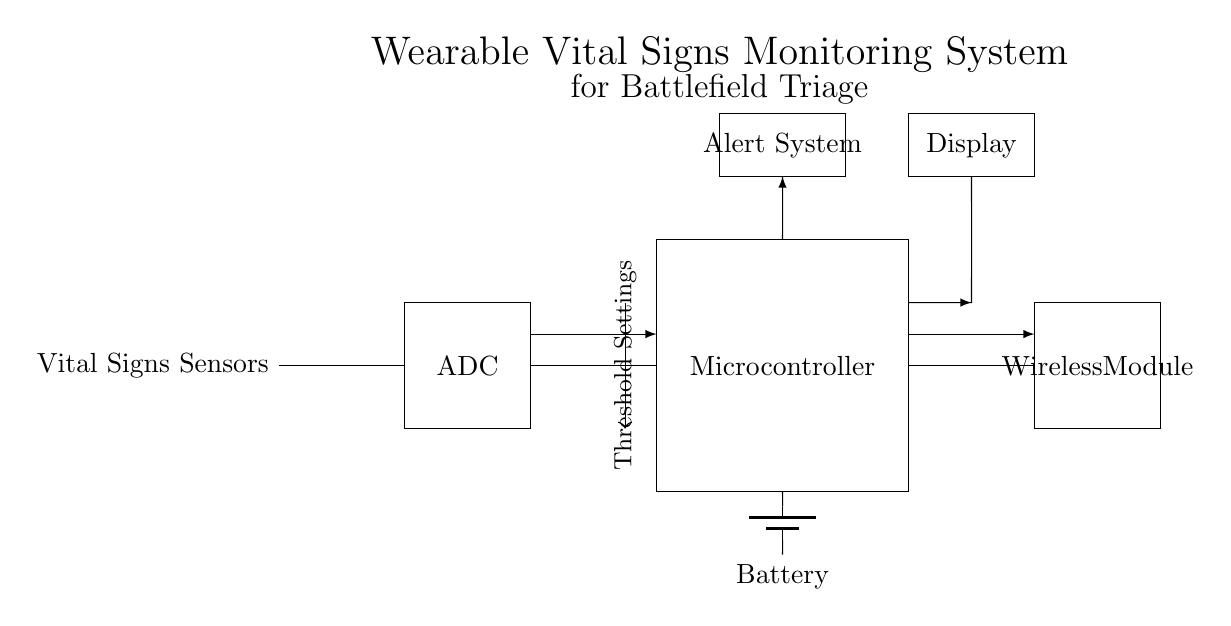What type of sensors are used in the circuit? The components labeled "Vital Signs Sensors" indicate that the circuit includes sensors specifically designed to monitor vital signs.
Answer: Vital Signs Sensors What is the main processing unit in the system? The diagram shows a rectangular block labeled "Microcontroller," which serves as the main processing unit to handle data from the sensors and control other components.
Answer: Microcontroller What component provides power to the circuit? The diagram displays a symbol for a battery labeled "Battery," which supplies electrical power to the entire system.
Answer: Battery How does the alert system communicate with other components? The alert system is connected with a line indicating a flow of data (arrow) towards it from the microcontroller, meaning it receives signals to trigger alerts.
Answer: Through data signals What is the function of the wireless module in this system? The wireless module is designed to communicate data outside of the device, likely transmitting the vital signs data to a remote location or monitoring station.
Answer: Data communication What is indicated by the threshold settings in the circuit? The notation points to thresholds that are configured to determine specific vital sign conditions that will trigger alerts, aiding in triage decisions.
Answer: Alert thresholds What role does the display serve in the monitoring system? The display unit shows real-time data from the sensors, allowing for immediate visual feedback on the monitored vital signs.
Answer: Real-time display 